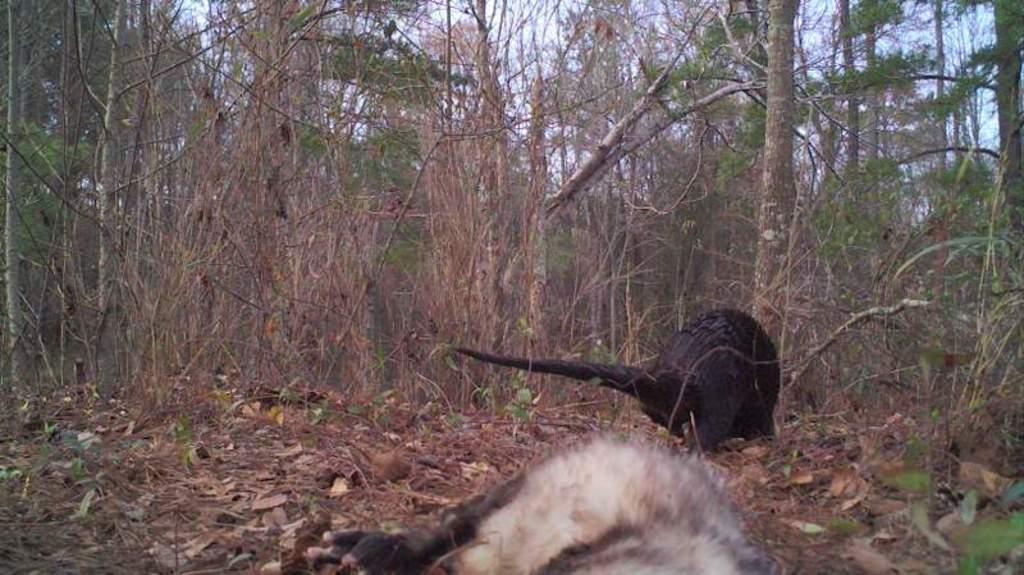Can you describe this image briefly? This image is clicked in the forest. In the front, we can see two animals. At the bottom, there are dried leaves. In the background, there are many trees. 